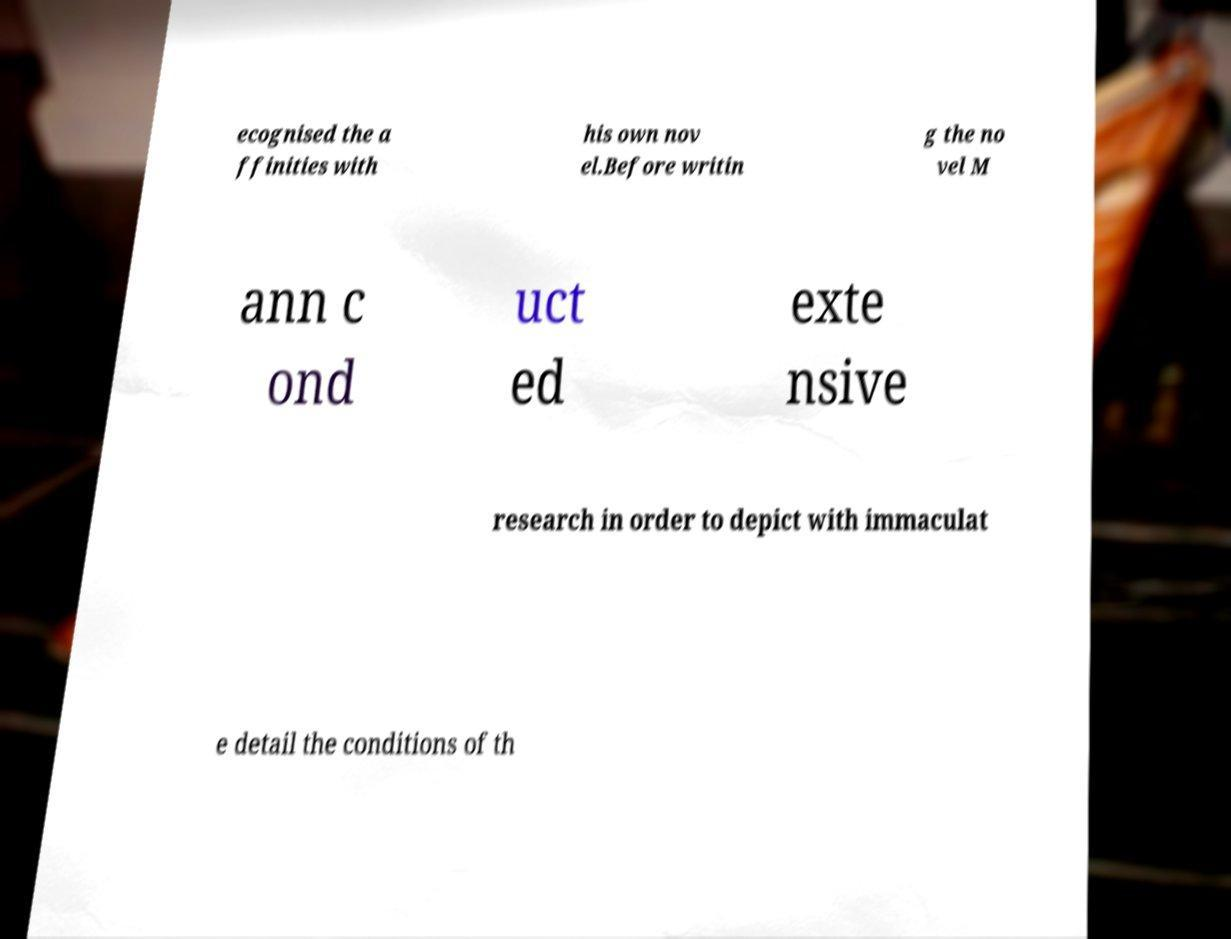Could you extract and type out the text from this image? ecognised the a ffinities with his own nov el.Before writin g the no vel M ann c ond uct ed exte nsive research in order to depict with immaculat e detail the conditions of th 